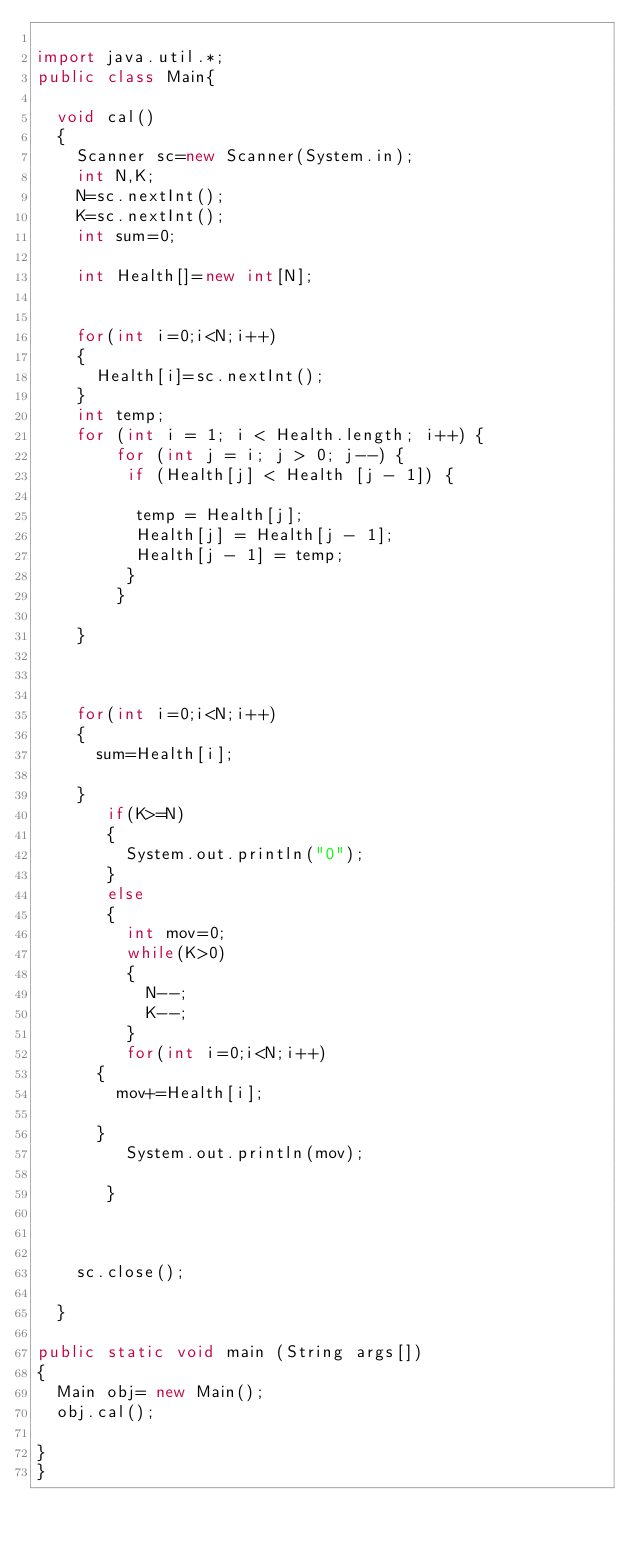Convert code to text. <code><loc_0><loc_0><loc_500><loc_500><_Java_>
import java.util.*;
public class Main{
	
	void cal()
	{
		Scanner sc=new Scanner(System.in);
		int N,K;
		N=sc.nextInt();
		K=sc.nextInt();
		int sum=0;
		
		int Health[]=new int[N];
		
		
		for(int i=0;i<N;i++)
		{
			Health[i]=sc.nextInt();				
		}
		int temp;
		for (int i = 1; i < Health.length; i++) {
		    for (int j = i; j > 0; j--) {
		     if (Health[j] < Health [j - 1]) {
		    	
		      temp = Health[j];
		      Health[j] = Health[j - 1];
		      Health[j - 1] = temp;
		     }
		    }
				
		}
	
		
		  
		for(int i=0;i<N;i++)
		{
			sum=Health[i];
				
		}
	     if(K>=N)
	     {
	    	 System.out.println("0");
	     }
	     else
	     {
	    	 int mov=0;
	    	 while(K>0)
	    	 {
	    		 N--;
	    		 K--;
	    	 }
	    	 for(int i=0;i<N;i++)
	 		{
	 			mov+=Health[i];
	 				
	 		}
	    	 System.out.println(mov);
	    	 
	     }
		
		
		
		sc.close();
		
	}

public static void main (String args[])
{
	Main obj= new Main();
	obj.cal();

}
}



</code> 